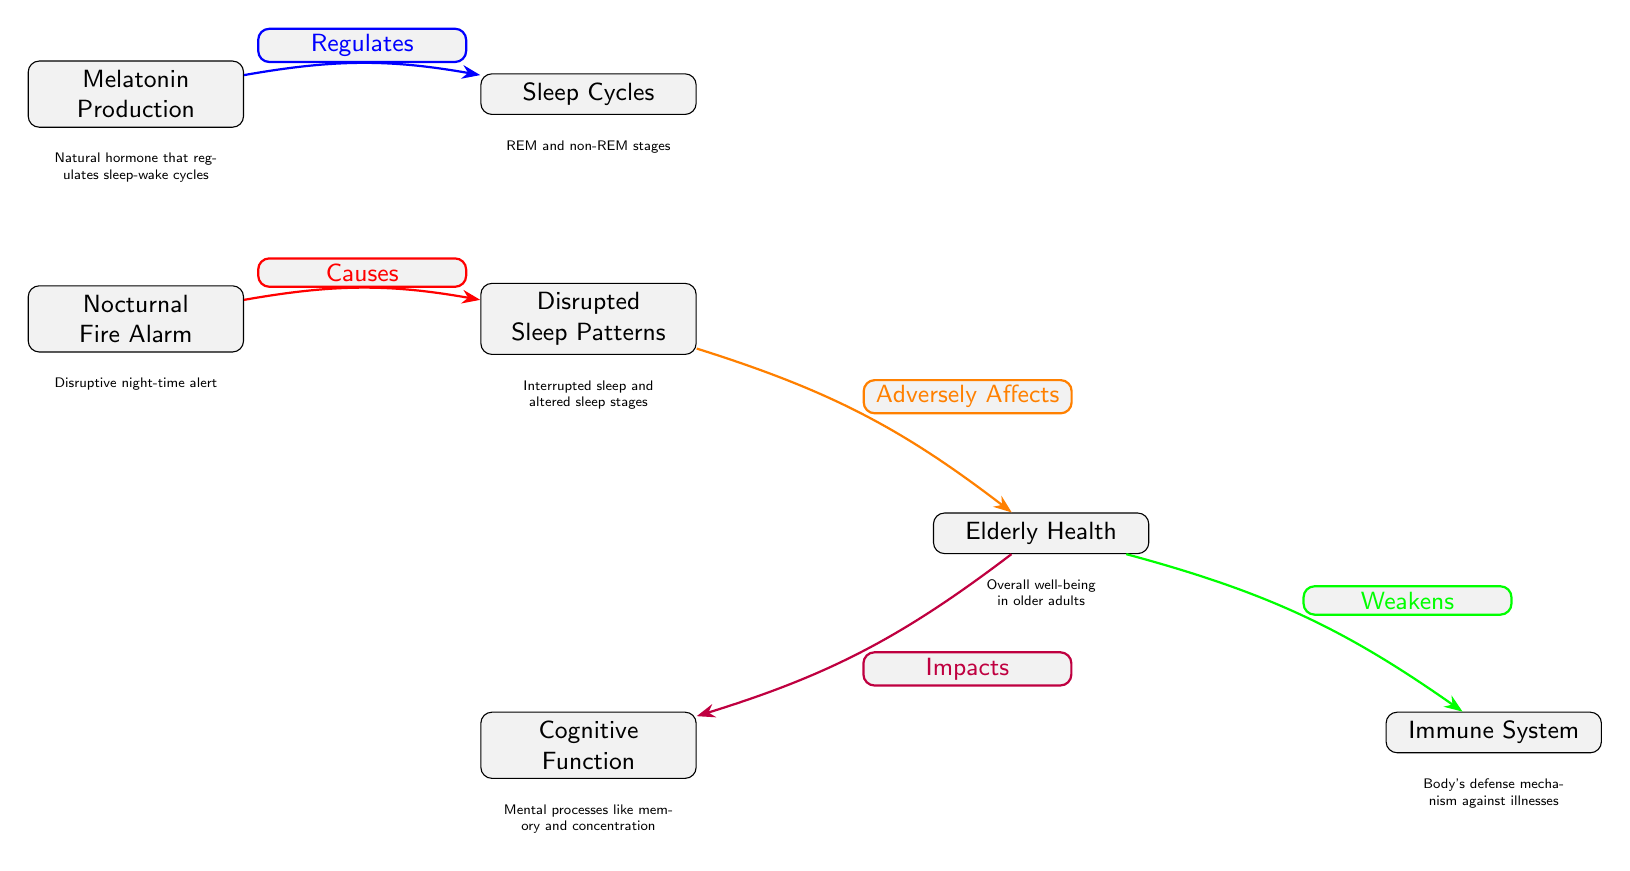What is the function of melatonin in this diagram? The diagram labels melatonin as a hormone that regulates sleep-wake cycles, indicating its role in managing when we sleep and when we wake up.
Answer: Regulates sleep-wake cycles How many main nodes are present in the diagram? By counting each labeled main node in the diagram, we find that there are six main nodes present: Melatonin Production, Sleep Cycles, Nocturnal Fire Alarm, Disrupted Sleep Patterns, Elderly Health, Cognitive Function, and Immune System.
Answer: Six What effect does the nocturnal fire alarm have on sleep patterns? The diagram states that the nocturnal fire alarm causes disrupted sleep patterns, indicating that the alarm is a disruptive factor affecting sleep quality during the night.
Answer: Causes disrupted sleep patterns Which node connects cognitive function and immune system? The diagram shows that both cognitive function and immune system are connected through the elderly health node. Elderly health is the common node that has outgoing edges to both cognitive function and immune system.
Answer: Elderly health What is the relationship between disrupted sleep patterns and elderly health? The diagram illustrates that disrupted sleep patterns adversely affect elderly health, suggesting a negative impact on the overall well-being of older adults resulting from disrupted sleep.
Answer: Adversely affects elderly health How does melatonin production influence sleep cycles? The diagram clearly states that melatonin production regulates sleep cycles, indicating that changes in melatonin levels can directly affect the body's ability to maintain healthy sleep patterns.
Answer: Regulates sleep cycles What two aspects of health are impacted by elderly health? The diagram shows two outgoing edges from the elderly health node, which indicate that it impacts cognitive function and weakens the immune system.
Answer: Cognitive function and immune system 